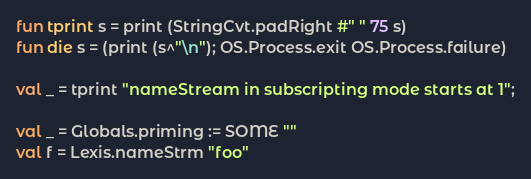<code> <loc_0><loc_0><loc_500><loc_500><_SML_>fun tprint s = print (StringCvt.padRight #" " 75 s)
fun die s = (print (s^"\n"); OS.Process.exit OS.Process.failure)

val _ = tprint "nameStream in subscripting mode starts at 1";

val _ = Globals.priming := SOME ""
val f = Lexis.nameStrm "foo"</code> 